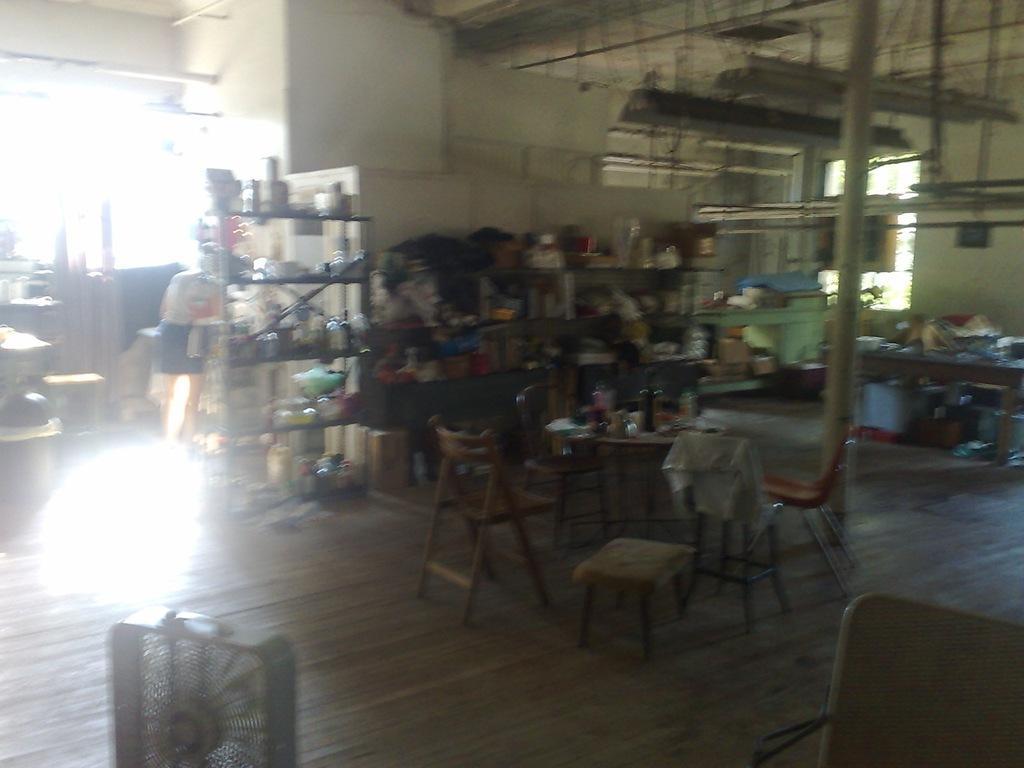Can you describe this image briefly? In this picture we can see a room with racks, chairs, stool, table and on table we have bottles and in the background we can see wall, some person standing, boxes, pillar, window, pipes, floor. 